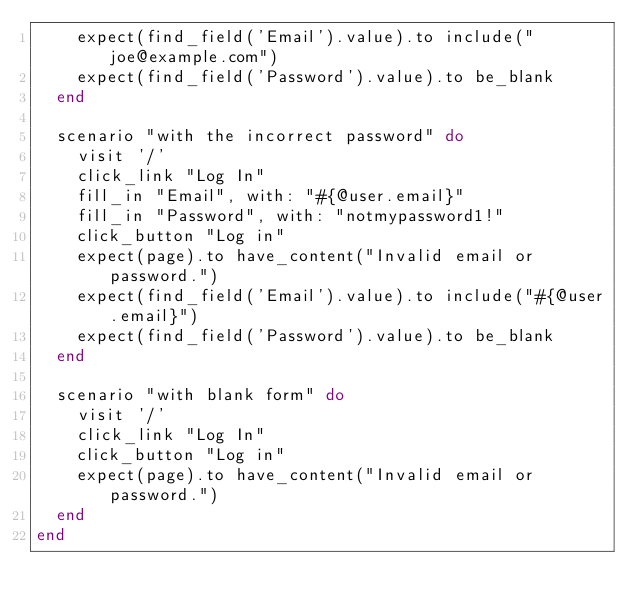<code> <loc_0><loc_0><loc_500><loc_500><_Ruby_>    expect(find_field('Email').value).to include("joe@example.com")
    expect(find_field('Password').value).to be_blank
  end

  scenario "with the incorrect password" do
    visit '/'
    click_link "Log In"
    fill_in "Email", with: "#{@user.email}"
    fill_in "Password", with: "notmypassword1!"
    click_button "Log in"
    expect(page).to have_content("Invalid email or password.")
    expect(find_field('Email').value).to include("#{@user.email}")
    expect(find_field('Password').value).to be_blank
  end

  scenario "with blank form" do
    visit '/'
    click_link "Log In"
    click_button "Log in"
    expect(page).to have_content("Invalid email or password.")
  end
end
</code> 